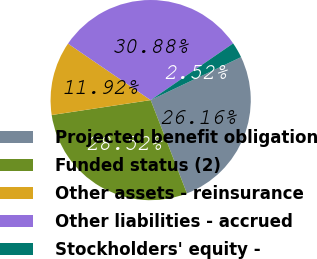<chart> <loc_0><loc_0><loc_500><loc_500><pie_chart><fcel>Projected benefit obligation<fcel>Funded status (2)<fcel>Other assets - reinsurance<fcel>Other liabilities - accrued<fcel>Stockholders' equity -<nl><fcel>26.16%<fcel>28.52%<fcel>11.92%<fcel>30.88%<fcel>2.52%<nl></chart> 